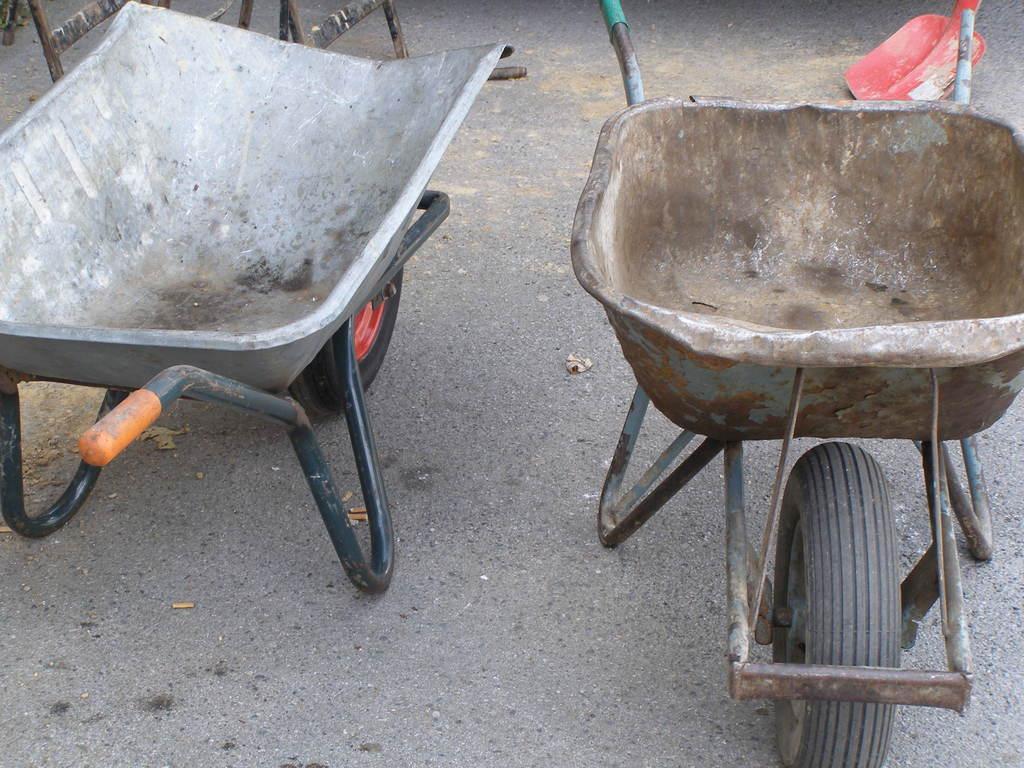Describe this image in one or two sentences. In this image, we can see two wheelbarrows on the road. 